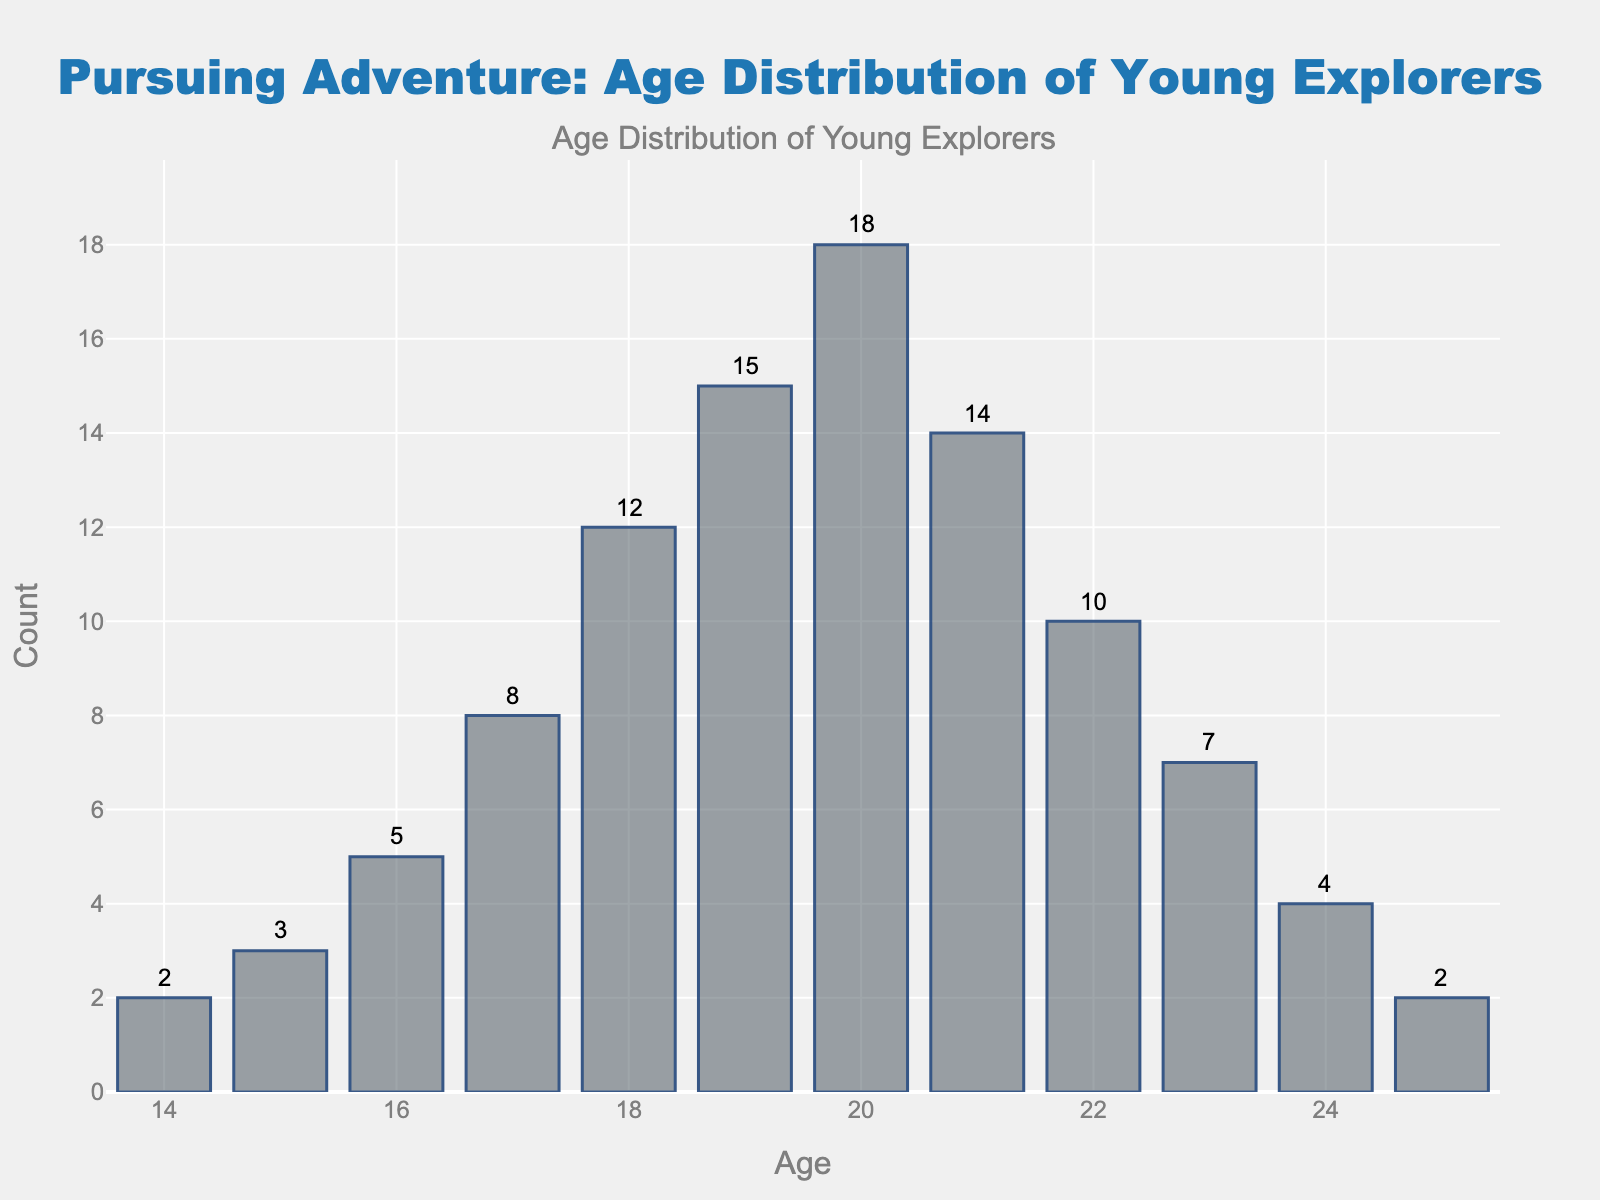What is the age range of the young explorers represented in the histogram? The histogram shows ages from 14 to 25 years old, as indicated by the x-axis labels.
Answer: 14 to 25 Which age group has the highest count of young explorers? The histogram bar for age 20 has the highest count, reaching up to 18 explorers.
Answer: Age 20 How does the count for age 17 compare to age 22? The count for age 17 is 8, and the count for age 22 is 10. Comparing these, age 22 has 2 more explorers than age 17.
Answer: Age 22 has 2 more explorers than age 17 What is the total count of young explorers aged between 18 and 21 inclusive? To find the total, add the counts for ages 18, 19, 20, and 21: 12 + 15 + 18 + 14 = 59.
Answer: 59 What is the smallest count recorded and at what age(s) is it observed? The smallest counts are 2, which is observed at ages 14 and 25.
Answer: Age 14 and Age 25 What is the average (mean) count of explorers between the ages 14 and 25? Sum all the counts: 2+3+5+8+12+15+18+14+10+7+4+2 = 100. The mean is 100 divided by the number of ages (12), so 100/12 ≈ 8.33.
Answer: Approximately 8.33 Is there a significant drop in the count after any specific age, and if so, what ages are involved? The counts notably drop after age 20, going from 18 at age 20 to 14 at age 21, and further down to 10 at age 22.
Answer: After age 20 How many age groups have a count greater than the mean count of roughly 8.33? The ages with counts greater than 8.33 are 17, 18, 19, 20, and 21. That makes 5 age groups.
Answer: 5 age groups Which two consecutive ages have the largest difference in the number of explorers? The largest difference between consecutive ages is between ages 20 (18 explorers) and 21 (14 explorers), which is a difference of 4 explorers.
Answer: Between ages 20 and 21 What proportion of the total young explorers are 19 and younger? First, calculate the sum for ages 14 to 19: 2 + 3 + 5 + 8 + 12 + 15 = 45. The total number of explorers is 100, so the proportion is 45/100 = 0.45.
Answer: 0.45 